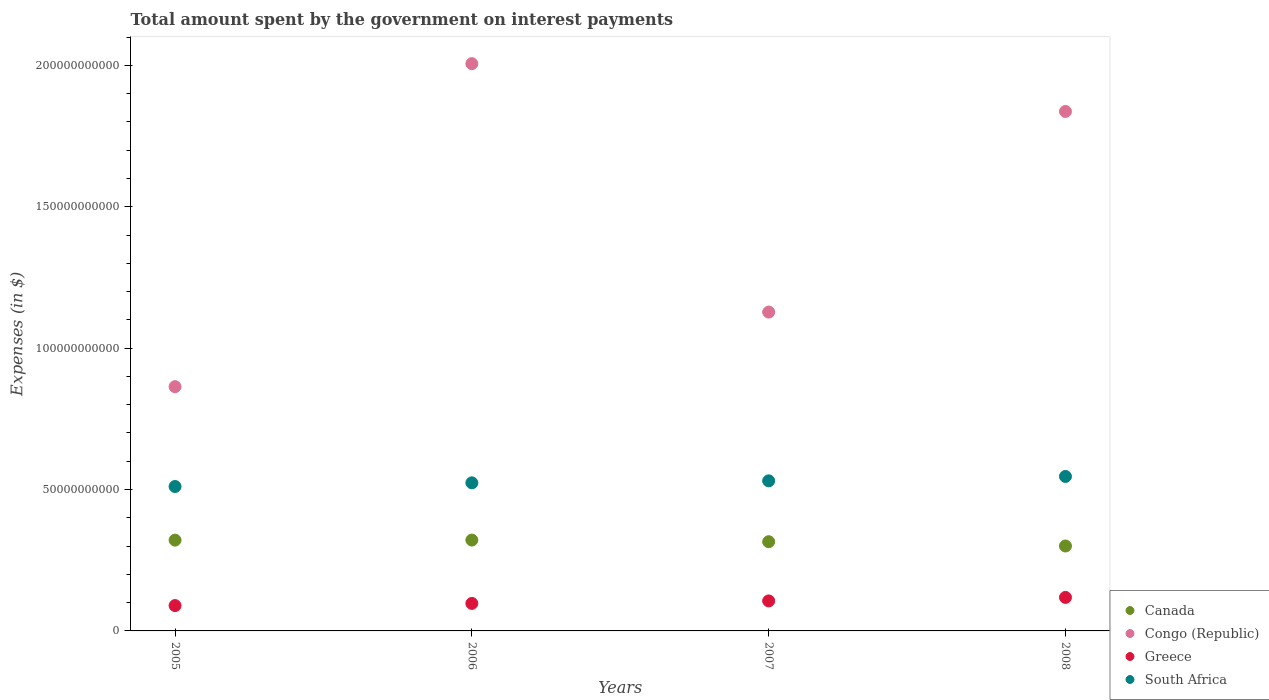Is the number of dotlines equal to the number of legend labels?
Keep it short and to the point. Yes. What is the amount spent on interest payments by the government in Greece in 2008?
Your answer should be compact. 1.19e+1. Across all years, what is the maximum amount spent on interest payments by the government in Canada?
Your answer should be compact. 3.21e+1. Across all years, what is the minimum amount spent on interest payments by the government in Congo (Republic)?
Offer a very short reply. 8.64e+1. In which year was the amount spent on interest payments by the government in Canada maximum?
Provide a short and direct response. 2006. What is the total amount spent on interest payments by the government in Congo (Republic) in the graph?
Your answer should be compact. 5.83e+11. What is the difference between the amount spent on interest payments by the government in Canada in 2007 and that in 2008?
Give a very brief answer. 1.52e+09. What is the difference between the amount spent on interest payments by the government in South Africa in 2006 and the amount spent on interest payments by the government in Greece in 2005?
Your response must be concise. 4.34e+1. What is the average amount spent on interest payments by the government in South Africa per year?
Provide a succinct answer. 5.28e+1. In the year 2005, what is the difference between the amount spent on interest payments by the government in Canada and amount spent on interest payments by the government in Congo (Republic)?
Make the answer very short. -5.43e+1. What is the ratio of the amount spent on interest payments by the government in Canada in 2005 to that in 2007?
Your answer should be very brief. 1.02. Is the amount spent on interest payments by the government in South Africa in 2005 less than that in 2007?
Offer a terse response. Yes. Is the difference between the amount spent on interest payments by the government in Canada in 2006 and 2008 greater than the difference between the amount spent on interest payments by the government in Congo (Republic) in 2006 and 2008?
Offer a terse response. No. What is the difference between the highest and the second highest amount spent on interest payments by the government in Canada?
Offer a terse response. 2.10e+07. What is the difference between the highest and the lowest amount spent on interest payments by the government in Canada?
Offer a terse response. 2.10e+09. In how many years, is the amount spent on interest payments by the government in Canada greater than the average amount spent on interest payments by the government in Canada taken over all years?
Make the answer very short. 3. Is the sum of the amount spent on interest payments by the government in South Africa in 2006 and 2008 greater than the maximum amount spent on interest payments by the government in Congo (Republic) across all years?
Your answer should be compact. No. Is it the case that in every year, the sum of the amount spent on interest payments by the government in Congo (Republic) and amount spent on interest payments by the government in Greece  is greater than the sum of amount spent on interest payments by the government in Canada and amount spent on interest payments by the government in South Africa?
Your response must be concise. No. How many years are there in the graph?
Give a very brief answer. 4. What is the difference between two consecutive major ticks on the Y-axis?
Make the answer very short. 5.00e+1. Are the values on the major ticks of Y-axis written in scientific E-notation?
Your answer should be compact. No. Does the graph contain grids?
Your answer should be compact. No. How many legend labels are there?
Provide a short and direct response. 4. What is the title of the graph?
Provide a succinct answer. Total amount spent by the government on interest payments. Does "Liberia" appear as one of the legend labels in the graph?
Provide a short and direct response. No. What is the label or title of the Y-axis?
Give a very brief answer. Expenses (in $). What is the Expenses (in $) in Canada in 2005?
Your response must be concise. 3.21e+1. What is the Expenses (in $) in Congo (Republic) in 2005?
Make the answer very short. 8.64e+1. What is the Expenses (in $) of Greece in 2005?
Offer a very short reply. 8.96e+09. What is the Expenses (in $) in South Africa in 2005?
Your response must be concise. 5.11e+1. What is the Expenses (in $) of Canada in 2006?
Your answer should be very brief. 3.21e+1. What is the Expenses (in $) in Congo (Republic) in 2006?
Offer a terse response. 2.01e+11. What is the Expenses (in $) of Greece in 2006?
Your response must be concise. 9.73e+09. What is the Expenses (in $) in South Africa in 2006?
Give a very brief answer. 5.24e+1. What is the Expenses (in $) of Canada in 2007?
Give a very brief answer. 3.16e+1. What is the Expenses (in $) in Congo (Republic) in 2007?
Offer a terse response. 1.13e+11. What is the Expenses (in $) in Greece in 2007?
Your answer should be compact. 1.06e+1. What is the Expenses (in $) of South Africa in 2007?
Your answer should be very brief. 5.31e+1. What is the Expenses (in $) in Canada in 2008?
Keep it short and to the point. 3.00e+1. What is the Expenses (in $) in Congo (Republic) in 2008?
Keep it short and to the point. 1.84e+11. What is the Expenses (in $) in Greece in 2008?
Give a very brief answer. 1.19e+1. What is the Expenses (in $) in South Africa in 2008?
Provide a succinct answer. 5.46e+1. Across all years, what is the maximum Expenses (in $) of Canada?
Make the answer very short. 3.21e+1. Across all years, what is the maximum Expenses (in $) in Congo (Republic)?
Your response must be concise. 2.01e+11. Across all years, what is the maximum Expenses (in $) of Greece?
Offer a very short reply. 1.19e+1. Across all years, what is the maximum Expenses (in $) in South Africa?
Give a very brief answer. 5.46e+1. Across all years, what is the minimum Expenses (in $) in Canada?
Offer a very short reply. 3.00e+1. Across all years, what is the minimum Expenses (in $) of Congo (Republic)?
Keep it short and to the point. 8.64e+1. Across all years, what is the minimum Expenses (in $) in Greece?
Provide a succinct answer. 8.96e+09. Across all years, what is the minimum Expenses (in $) of South Africa?
Offer a terse response. 5.11e+1. What is the total Expenses (in $) in Canada in the graph?
Your response must be concise. 1.26e+11. What is the total Expenses (in $) in Congo (Republic) in the graph?
Give a very brief answer. 5.83e+11. What is the total Expenses (in $) in Greece in the graph?
Keep it short and to the point. 4.12e+1. What is the total Expenses (in $) in South Africa in the graph?
Give a very brief answer. 2.11e+11. What is the difference between the Expenses (in $) in Canada in 2005 and that in 2006?
Your answer should be compact. -2.10e+07. What is the difference between the Expenses (in $) of Congo (Republic) in 2005 and that in 2006?
Give a very brief answer. -1.14e+11. What is the difference between the Expenses (in $) of Greece in 2005 and that in 2006?
Provide a succinct answer. -7.66e+08. What is the difference between the Expenses (in $) of South Africa in 2005 and that in 2006?
Ensure brevity in your answer.  -1.30e+09. What is the difference between the Expenses (in $) of Canada in 2005 and that in 2007?
Provide a succinct answer. 5.58e+08. What is the difference between the Expenses (in $) in Congo (Republic) in 2005 and that in 2007?
Make the answer very short. -2.64e+1. What is the difference between the Expenses (in $) of Greece in 2005 and that in 2007?
Give a very brief answer. -1.65e+09. What is the difference between the Expenses (in $) of South Africa in 2005 and that in 2007?
Your response must be concise. -2.01e+09. What is the difference between the Expenses (in $) of Canada in 2005 and that in 2008?
Your response must be concise. 2.08e+09. What is the difference between the Expenses (in $) in Congo (Republic) in 2005 and that in 2008?
Keep it short and to the point. -9.73e+1. What is the difference between the Expenses (in $) in Greece in 2005 and that in 2008?
Ensure brevity in your answer.  -2.89e+09. What is the difference between the Expenses (in $) in South Africa in 2005 and that in 2008?
Keep it short and to the point. -3.56e+09. What is the difference between the Expenses (in $) of Canada in 2006 and that in 2007?
Make the answer very short. 5.79e+08. What is the difference between the Expenses (in $) in Congo (Republic) in 2006 and that in 2007?
Your response must be concise. 8.79e+1. What is the difference between the Expenses (in $) of Greece in 2006 and that in 2007?
Your answer should be compact. -8.87e+08. What is the difference between the Expenses (in $) of South Africa in 2006 and that in 2007?
Your answer should be very brief. -7.05e+08. What is the difference between the Expenses (in $) of Canada in 2006 and that in 2008?
Make the answer very short. 2.10e+09. What is the difference between the Expenses (in $) in Congo (Republic) in 2006 and that in 2008?
Provide a succinct answer. 1.69e+1. What is the difference between the Expenses (in $) of Greece in 2006 and that in 2008?
Your answer should be compact. -2.13e+09. What is the difference between the Expenses (in $) of South Africa in 2006 and that in 2008?
Give a very brief answer. -2.26e+09. What is the difference between the Expenses (in $) in Canada in 2007 and that in 2008?
Provide a short and direct response. 1.52e+09. What is the difference between the Expenses (in $) in Congo (Republic) in 2007 and that in 2008?
Provide a short and direct response. -7.10e+1. What is the difference between the Expenses (in $) in Greece in 2007 and that in 2008?
Ensure brevity in your answer.  -1.24e+09. What is the difference between the Expenses (in $) of South Africa in 2007 and that in 2008?
Offer a very short reply. -1.55e+09. What is the difference between the Expenses (in $) of Canada in 2005 and the Expenses (in $) of Congo (Republic) in 2006?
Keep it short and to the point. -1.69e+11. What is the difference between the Expenses (in $) of Canada in 2005 and the Expenses (in $) of Greece in 2006?
Provide a short and direct response. 2.24e+1. What is the difference between the Expenses (in $) of Canada in 2005 and the Expenses (in $) of South Africa in 2006?
Your answer should be compact. -2.03e+1. What is the difference between the Expenses (in $) of Congo (Republic) in 2005 and the Expenses (in $) of Greece in 2006?
Keep it short and to the point. 7.67e+1. What is the difference between the Expenses (in $) in Congo (Republic) in 2005 and the Expenses (in $) in South Africa in 2006?
Your answer should be very brief. 3.40e+1. What is the difference between the Expenses (in $) of Greece in 2005 and the Expenses (in $) of South Africa in 2006?
Provide a short and direct response. -4.34e+1. What is the difference between the Expenses (in $) of Canada in 2005 and the Expenses (in $) of Congo (Republic) in 2007?
Keep it short and to the point. -8.07e+1. What is the difference between the Expenses (in $) in Canada in 2005 and the Expenses (in $) in Greece in 2007?
Offer a very short reply. 2.15e+1. What is the difference between the Expenses (in $) in Canada in 2005 and the Expenses (in $) in South Africa in 2007?
Ensure brevity in your answer.  -2.10e+1. What is the difference between the Expenses (in $) of Congo (Republic) in 2005 and the Expenses (in $) of Greece in 2007?
Offer a very short reply. 7.58e+1. What is the difference between the Expenses (in $) in Congo (Republic) in 2005 and the Expenses (in $) in South Africa in 2007?
Keep it short and to the point. 3.33e+1. What is the difference between the Expenses (in $) in Greece in 2005 and the Expenses (in $) in South Africa in 2007?
Offer a very short reply. -4.41e+1. What is the difference between the Expenses (in $) in Canada in 2005 and the Expenses (in $) in Congo (Republic) in 2008?
Your answer should be very brief. -1.52e+11. What is the difference between the Expenses (in $) of Canada in 2005 and the Expenses (in $) of Greece in 2008?
Your answer should be compact. 2.03e+1. What is the difference between the Expenses (in $) of Canada in 2005 and the Expenses (in $) of South Africa in 2008?
Provide a succinct answer. -2.25e+1. What is the difference between the Expenses (in $) in Congo (Republic) in 2005 and the Expenses (in $) in Greece in 2008?
Provide a succinct answer. 7.45e+1. What is the difference between the Expenses (in $) in Congo (Republic) in 2005 and the Expenses (in $) in South Africa in 2008?
Provide a succinct answer. 3.17e+1. What is the difference between the Expenses (in $) of Greece in 2005 and the Expenses (in $) of South Africa in 2008?
Your answer should be compact. -4.57e+1. What is the difference between the Expenses (in $) of Canada in 2006 and the Expenses (in $) of Congo (Republic) in 2007?
Provide a succinct answer. -8.06e+1. What is the difference between the Expenses (in $) in Canada in 2006 and the Expenses (in $) in Greece in 2007?
Offer a terse response. 2.15e+1. What is the difference between the Expenses (in $) of Canada in 2006 and the Expenses (in $) of South Africa in 2007?
Provide a succinct answer. -2.09e+1. What is the difference between the Expenses (in $) of Congo (Republic) in 2006 and the Expenses (in $) of Greece in 2007?
Provide a succinct answer. 1.90e+11. What is the difference between the Expenses (in $) of Congo (Republic) in 2006 and the Expenses (in $) of South Africa in 2007?
Provide a short and direct response. 1.48e+11. What is the difference between the Expenses (in $) in Greece in 2006 and the Expenses (in $) in South Africa in 2007?
Provide a short and direct response. -4.34e+1. What is the difference between the Expenses (in $) of Canada in 2006 and the Expenses (in $) of Congo (Republic) in 2008?
Make the answer very short. -1.52e+11. What is the difference between the Expenses (in $) in Canada in 2006 and the Expenses (in $) in Greece in 2008?
Give a very brief answer. 2.03e+1. What is the difference between the Expenses (in $) in Canada in 2006 and the Expenses (in $) in South Africa in 2008?
Keep it short and to the point. -2.25e+1. What is the difference between the Expenses (in $) of Congo (Republic) in 2006 and the Expenses (in $) of Greece in 2008?
Your answer should be compact. 1.89e+11. What is the difference between the Expenses (in $) of Congo (Republic) in 2006 and the Expenses (in $) of South Africa in 2008?
Your answer should be compact. 1.46e+11. What is the difference between the Expenses (in $) of Greece in 2006 and the Expenses (in $) of South Africa in 2008?
Offer a terse response. -4.49e+1. What is the difference between the Expenses (in $) in Canada in 2007 and the Expenses (in $) in Congo (Republic) in 2008?
Offer a terse response. -1.52e+11. What is the difference between the Expenses (in $) of Canada in 2007 and the Expenses (in $) of Greece in 2008?
Offer a very short reply. 1.97e+1. What is the difference between the Expenses (in $) of Canada in 2007 and the Expenses (in $) of South Africa in 2008?
Your response must be concise. -2.31e+1. What is the difference between the Expenses (in $) of Congo (Republic) in 2007 and the Expenses (in $) of Greece in 2008?
Give a very brief answer. 1.01e+11. What is the difference between the Expenses (in $) of Congo (Republic) in 2007 and the Expenses (in $) of South Africa in 2008?
Provide a succinct answer. 5.81e+1. What is the difference between the Expenses (in $) in Greece in 2007 and the Expenses (in $) in South Africa in 2008?
Your answer should be compact. -4.40e+1. What is the average Expenses (in $) in Canada per year?
Provide a short and direct response. 3.15e+1. What is the average Expenses (in $) of Congo (Republic) per year?
Offer a very short reply. 1.46e+11. What is the average Expenses (in $) in Greece per year?
Offer a terse response. 1.03e+1. What is the average Expenses (in $) of South Africa per year?
Offer a terse response. 5.28e+1. In the year 2005, what is the difference between the Expenses (in $) in Canada and Expenses (in $) in Congo (Republic)?
Your answer should be very brief. -5.43e+1. In the year 2005, what is the difference between the Expenses (in $) in Canada and Expenses (in $) in Greece?
Your response must be concise. 2.32e+1. In the year 2005, what is the difference between the Expenses (in $) in Canada and Expenses (in $) in South Africa?
Provide a succinct answer. -1.90e+1. In the year 2005, what is the difference between the Expenses (in $) of Congo (Republic) and Expenses (in $) of Greece?
Provide a short and direct response. 7.74e+1. In the year 2005, what is the difference between the Expenses (in $) in Congo (Republic) and Expenses (in $) in South Africa?
Keep it short and to the point. 3.53e+1. In the year 2005, what is the difference between the Expenses (in $) in Greece and Expenses (in $) in South Africa?
Ensure brevity in your answer.  -4.21e+1. In the year 2006, what is the difference between the Expenses (in $) in Canada and Expenses (in $) in Congo (Republic)?
Offer a terse response. -1.68e+11. In the year 2006, what is the difference between the Expenses (in $) in Canada and Expenses (in $) in Greece?
Offer a very short reply. 2.24e+1. In the year 2006, what is the difference between the Expenses (in $) of Canada and Expenses (in $) of South Africa?
Your response must be concise. -2.02e+1. In the year 2006, what is the difference between the Expenses (in $) of Congo (Republic) and Expenses (in $) of Greece?
Give a very brief answer. 1.91e+11. In the year 2006, what is the difference between the Expenses (in $) of Congo (Republic) and Expenses (in $) of South Africa?
Your answer should be very brief. 1.48e+11. In the year 2006, what is the difference between the Expenses (in $) of Greece and Expenses (in $) of South Africa?
Offer a very short reply. -4.26e+1. In the year 2007, what is the difference between the Expenses (in $) in Canada and Expenses (in $) in Congo (Republic)?
Provide a short and direct response. -8.12e+1. In the year 2007, what is the difference between the Expenses (in $) in Canada and Expenses (in $) in Greece?
Provide a succinct answer. 2.09e+1. In the year 2007, what is the difference between the Expenses (in $) in Canada and Expenses (in $) in South Africa?
Keep it short and to the point. -2.15e+1. In the year 2007, what is the difference between the Expenses (in $) in Congo (Republic) and Expenses (in $) in Greece?
Give a very brief answer. 1.02e+11. In the year 2007, what is the difference between the Expenses (in $) of Congo (Republic) and Expenses (in $) of South Africa?
Your answer should be very brief. 5.97e+1. In the year 2007, what is the difference between the Expenses (in $) of Greece and Expenses (in $) of South Africa?
Give a very brief answer. -4.25e+1. In the year 2008, what is the difference between the Expenses (in $) in Canada and Expenses (in $) in Congo (Republic)?
Your answer should be compact. -1.54e+11. In the year 2008, what is the difference between the Expenses (in $) of Canada and Expenses (in $) of Greece?
Your response must be concise. 1.82e+1. In the year 2008, what is the difference between the Expenses (in $) in Canada and Expenses (in $) in South Africa?
Ensure brevity in your answer.  -2.46e+1. In the year 2008, what is the difference between the Expenses (in $) in Congo (Republic) and Expenses (in $) in Greece?
Provide a short and direct response. 1.72e+11. In the year 2008, what is the difference between the Expenses (in $) of Congo (Republic) and Expenses (in $) of South Africa?
Make the answer very short. 1.29e+11. In the year 2008, what is the difference between the Expenses (in $) in Greece and Expenses (in $) in South Africa?
Give a very brief answer. -4.28e+1. What is the ratio of the Expenses (in $) of Canada in 2005 to that in 2006?
Offer a terse response. 1. What is the ratio of the Expenses (in $) of Congo (Republic) in 2005 to that in 2006?
Offer a terse response. 0.43. What is the ratio of the Expenses (in $) in Greece in 2005 to that in 2006?
Keep it short and to the point. 0.92. What is the ratio of the Expenses (in $) of South Africa in 2005 to that in 2006?
Offer a terse response. 0.98. What is the ratio of the Expenses (in $) of Canada in 2005 to that in 2007?
Offer a terse response. 1.02. What is the ratio of the Expenses (in $) of Congo (Republic) in 2005 to that in 2007?
Provide a short and direct response. 0.77. What is the ratio of the Expenses (in $) in Greece in 2005 to that in 2007?
Provide a succinct answer. 0.84. What is the ratio of the Expenses (in $) of South Africa in 2005 to that in 2007?
Ensure brevity in your answer.  0.96. What is the ratio of the Expenses (in $) of Canada in 2005 to that in 2008?
Your answer should be compact. 1.07. What is the ratio of the Expenses (in $) of Congo (Republic) in 2005 to that in 2008?
Give a very brief answer. 0.47. What is the ratio of the Expenses (in $) in Greece in 2005 to that in 2008?
Keep it short and to the point. 0.76. What is the ratio of the Expenses (in $) in South Africa in 2005 to that in 2008?
Your response must be concise. 0.93. What is the ratio of the Expenses (in $) of Canada in 2006 to that in 2007?
Provide a succinct answer. 1.02. What is the ratio of the Expenses (in $) of Congo (Republic) in 2006 to that in 2007?
Ensure brevity in your answer.  1.78. What is the ratio of the Expenses (in $) of Greece in 2006 to that in 2007?
Your answer should be very brief. 0.92. What is the ratio of the Expenses (in $) in South Africa in 2006 to that in 2007?
Your answer should be very brief. 0.99. What is the ratio of the Expenses (in $) in Canada in 2006 to that in 2008?
Your response must be concise. 1.07. What is the ratio of the Expenses (in $) of Congo (Republic) in 2006 to that in 2008?
Your response must be concise. 1.09. What is the ratio of the Expenses (in $) of Greece in 2006 to that in 2008?
Offer a very short reply. 0.82. What is the ratio of the Expenses (in $) in South Africa in 2006 to that in 2008?
Provide a succinct answer. 0.96. What is the ratio of the Expenses (in $) in Canada in 2007 to that in 2008?
Ensure brevity in your answer.  1.05. What is the ratio of the Expenses (in $) of Congo (Republic) in 2007 to that in 2008?
Offer a very short reply. 0.61. What is the ratio of the Expenses (in $) in Greece in 2007 to that in 2008?
Offer a terse response. 0.9. What is the ratio of the Expenses (in $) in South Africa in 2007 to that in 2008?
Give a very brief answer. 0.97. What is the difference between the highest and the second highest Expenses (in $) of Canada?
Your response must be concise. 2.10e+07. What is the difference between the highest and the second highest Expenses (in $) in Congo (Republic)?
Provide a short and direct response. 1.69e+1. What is the difference between the highest and the second highest Expenses (in $) of Greece?
Your response must be concise. 1.24e+09. What is the difference between the highest and the second highest Expenses (in $) in South Africa?
Offer a terse response. 1.55e+09. What is the difference between the highest and the lowest Expenses (in $) of Canada?
Your answer should be very brief. 2.10e+09. What is the difference between the highest and the lowest Expenses (in $) of Congo (Republic)?
Your answer should be very brief. 1.14e+11. What is the difference between the highest and the lowest Expenses (in $) in Greece?
Your response must be concise. 2.89e+09. What is the difference between the highest and the lowest Expenses (in $) of South Africa?
Your answer should be compact. 3.56e+09. 